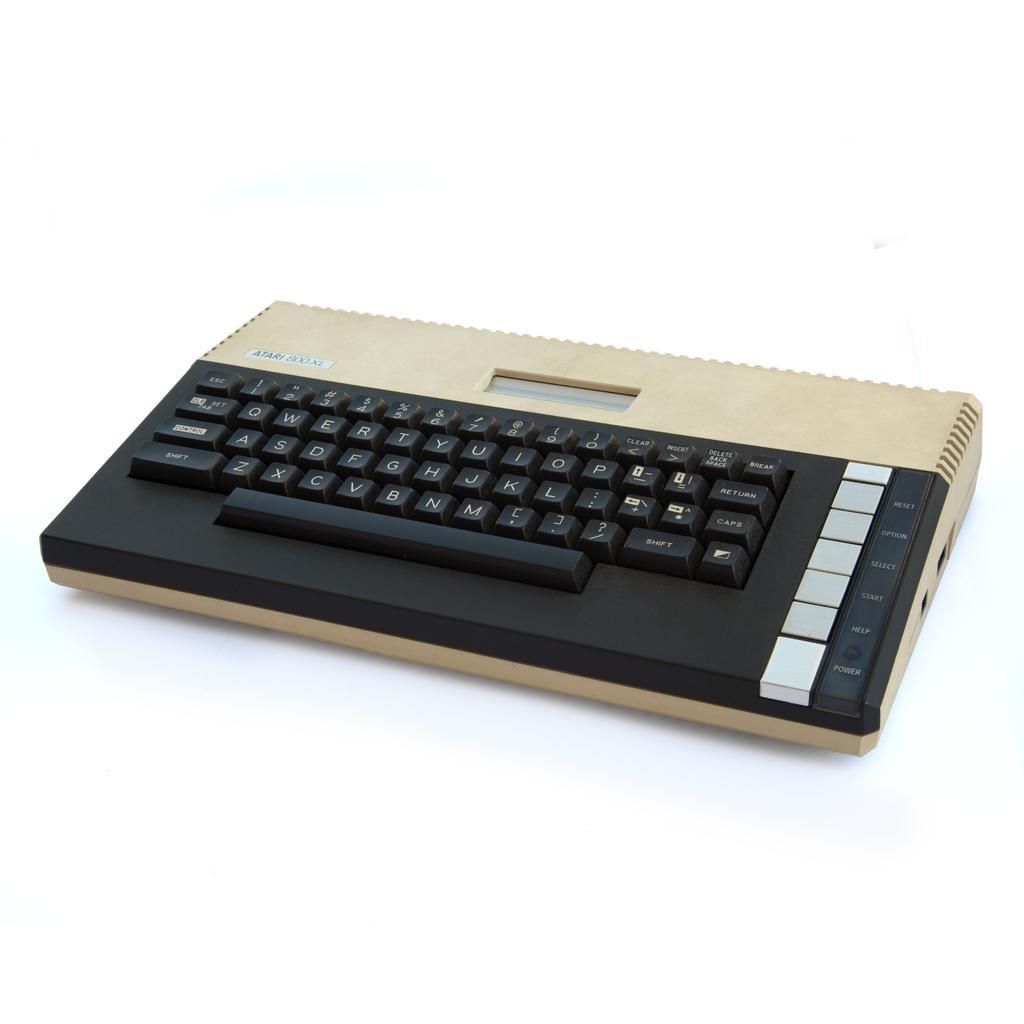<image>
Render a clear and concise summary of the photo. a keyboard with a select button in the bottom right 